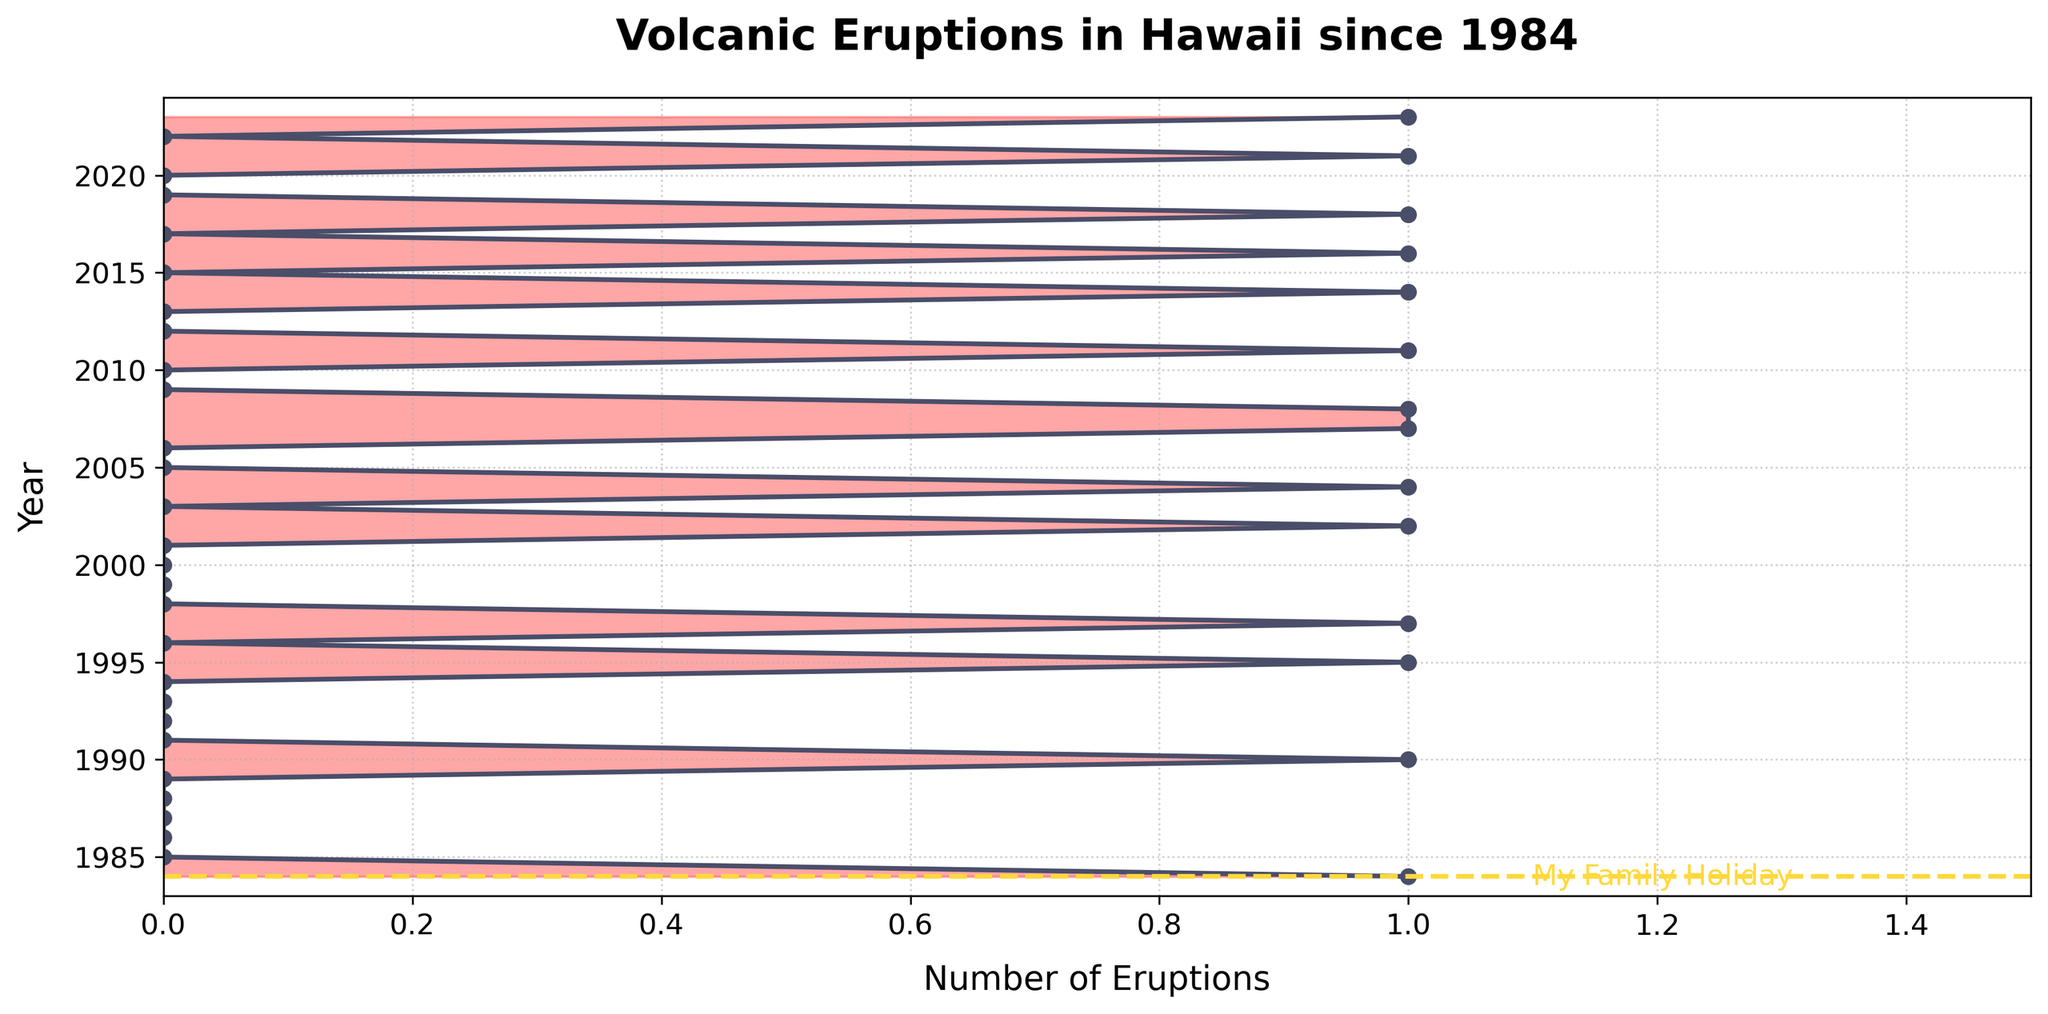When was the last volcanic eruption in Hawaii according to the figure? Look at the data points marked on the figure. The rightmost data point represents the last recorded eruption, which happens in 2023.
Answer: 2023 How many years experienced more than one volcanic eruption? By inspecting the density values for each year in the figure, we see that no year has a density value exceeding 1, indicating no year experienced more than one eruption.
Answer: 0 What year is highlighted with the text "My Family Holiday" on the plot? A vertical line and text are visibly marked on the 1984 on the y-axis, indicating "My Family Holiday."
Answer: 1984 How many total eruptions occurred from 2005 to 2015? Count the data points representing eruptions for the years 2005, 2007, 2008, 2011, and 2014. Summing these gives 1 (2005) + 1 (2007) + 1 (2008) + 1 (2011) + 1 (2014) = 5 eruptions.
Answer: 5 What's the average number of years between consecutive eruptions from 1984 to 2023? To get the average number of years between eruptions, count the intervals between consecutive eruption years: 6 (from 1984 to 1990), 5 (from 1990 to 1995), 2, 5, 1, 4, 2, 4, 1, 3, 2, 2, 2, 2, 1. Sum the intervals and divide by the number of intervals: (6 + 5 + 2 + 5 + 1 + 4 + 2 + 4 + 1 + 3 + 2 + 2 + 2 + 2 + 1) / 15 = 2.6 years.
Answer: 2.6 years Which year saw the highest number of eruptions after 2000? Check the years after 2000 with eruptions: 2002, 2004, 2007, 2008, 2011, 2014, 2016, 2018, 2021, and 2023. Since each has exactly 1 eruption, they all tie for the highest.
Answer: 2002, 2004, 2007, 2008, 2011, 2014, 2016, 2018, 2021, 2023 How does the number of eruptions from 1984-2004 compare with those from 2005-2023? Count eruptions from 1984-2004: 1 (1984), 1 (1990), 1 (1995), 1 (1997), 1 (2002), 1 (2004) = 6. Count eruptions from 2005-2023: 1 (2005), 1 (2007), 1 (2008), 1 (2011), 1 (2014), 1 (2016), 1 (2018), 1 (2021), 1 (2023) = 9. Comparatively, 9 is greater than 6.
Answer: 1984-2004: 6, 2005-2023: 9, more in 2005-2023 What's the maximum number of consecutive years without any eruptions shown in the figure? Find the longest span of consecutive zeros in the data: 1985-1989 (5 years), 1998-2001 (4 years), 2009-2010 (2 years), 2012-2013 (2 years), 2019-2020 (2 years). The maximum span is 1985-1989, lasting 5 years.
Answer: 5 years In how many years did eruptions occur consecutively without any breaks? Identify consecutive years with eruptions from the plotted data: 2007-2008. Thus, eruptions occurred consecutively in 1 pair of years.
Answer: 1 year pair 